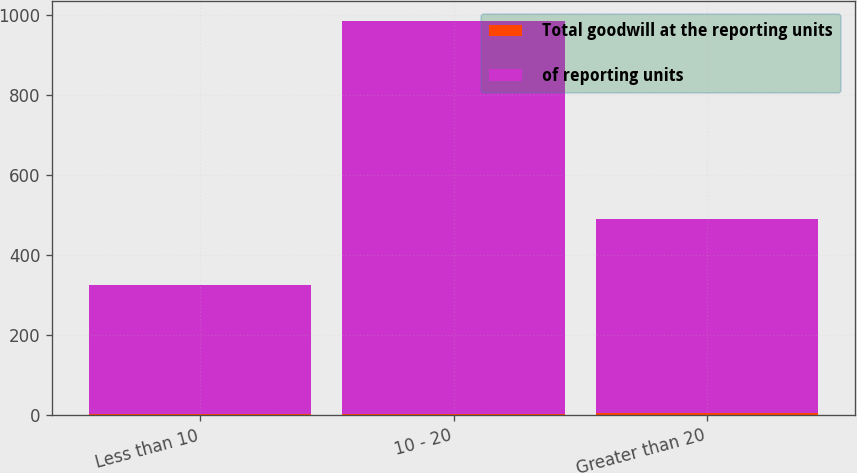Convert chart to OTSL. <chart><loc_0><loc_0><loc_500><loc_500><stacked_bar_chart><ecel><fcel>Less than 10<fcel>10 - 20<fcel>Greater than 20<nl><fcel>Total goodwill at the reporting units<fcel>2<fcel>3<fcel>4<nl><fcel>of reporting units<fcel>321.9<fcel>982<fcel>485.4<nl></chart> 